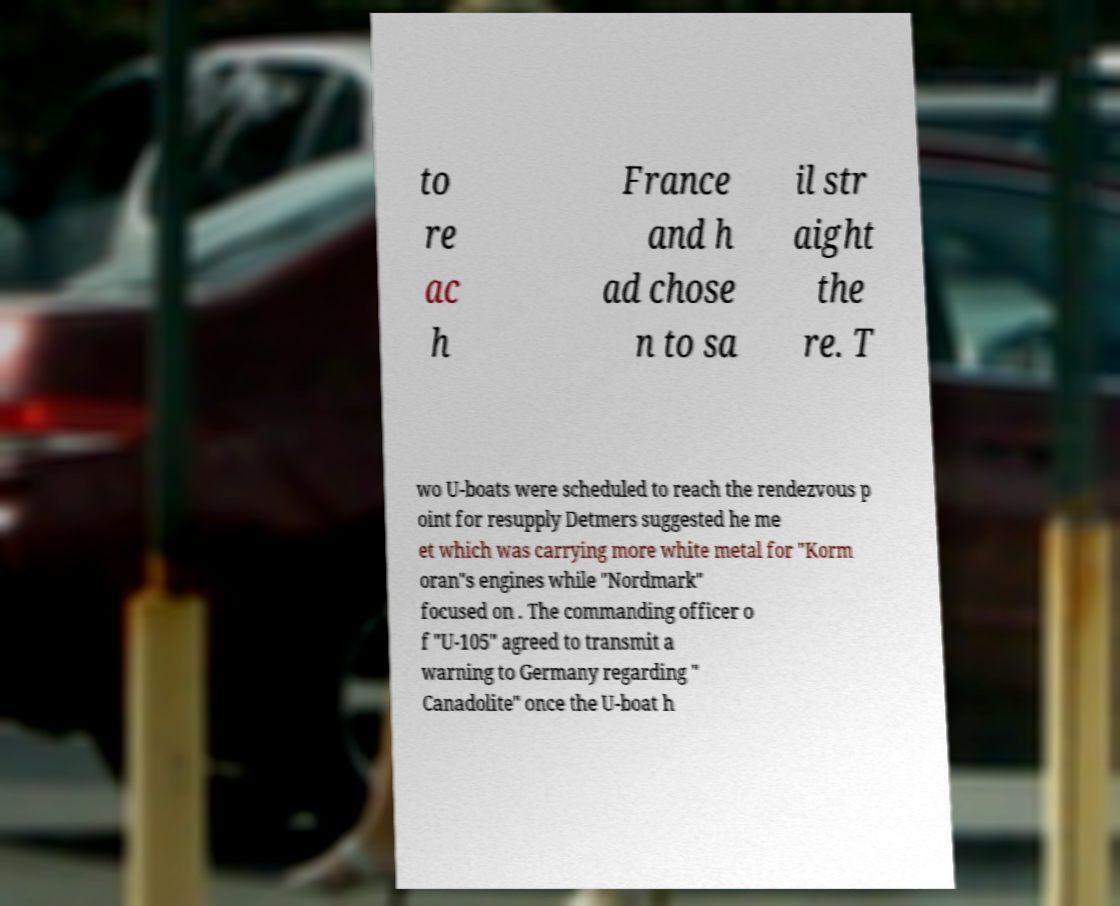Please identify and transcribe the text found in this image. to re ac h France and h ad chose n to sa il str aight the re. T wo U-boats were scheduled to reach the rendezvous p oint for resupply Detmers suggested he me et which was carrying more white metal for "Korm oran"s engines while "Nordmark" focused on . The commanding officer o f "U-105" agreed to transmit a warning to Germany regarding " Canadolite" once the U-boat h 